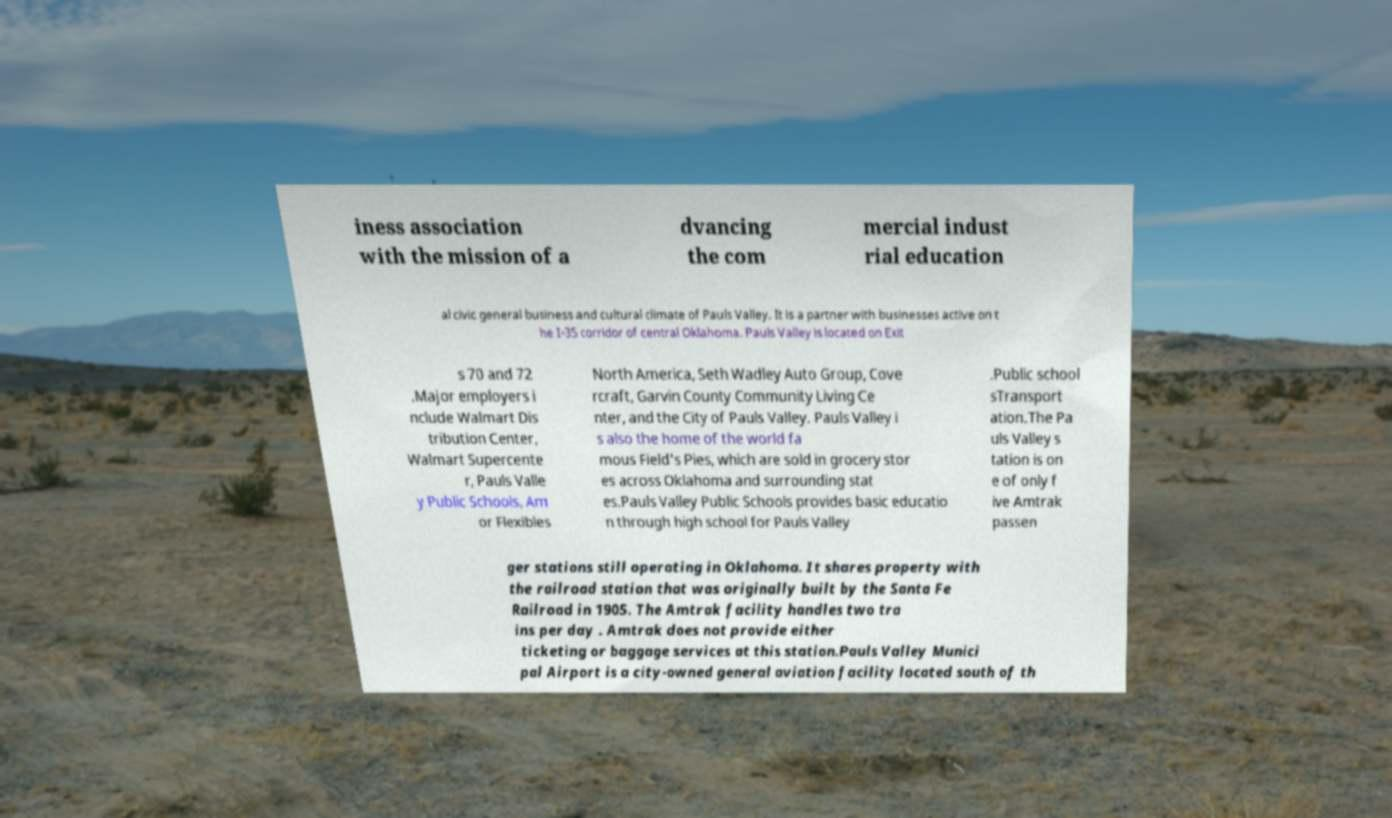Can you accurately transcribe the text from the provided image for me? iness association with the mission of a dvancing the com mercial indust rial education al civic general business and cultural climate of Pauls Valley. It is a partner with businesses active on t he I-35 corridor of central Oklahoma. Pauls Valley is located on Exit s 70 and 72 .Major employers i nclude Walmart Dis tribution Center, Walmart Supercente r, Pauls Valle y Public Schools, Am or Flexibles North America, Seth Wadley Auto Group, Cove rcraft, Garvin County Community Living Ce nter, and the City of Pauls Valley. Pauls Valley i s also the home of the world fa mous Field's Pies, which are sold in grocery stor es across Oklahoma and surrounding stat es.Pauls Valley Public Schools provides basic educatio n through high school for Pauls Valley .Public school sTransport ation.The Pa uls Valley s tation is on e of only f ive Amtrak passen ger stations still operating in Oklahoma. It shares property with the railroad station that was originally built by the Santa Fe Railroad in 1905. The Amtrak facility handles two tra ins per day . Amtrak does not provide either ticketing or baggage services at this station.Pauls Valley Munici pal Airport is a city-owned general aviation facility located south of th 